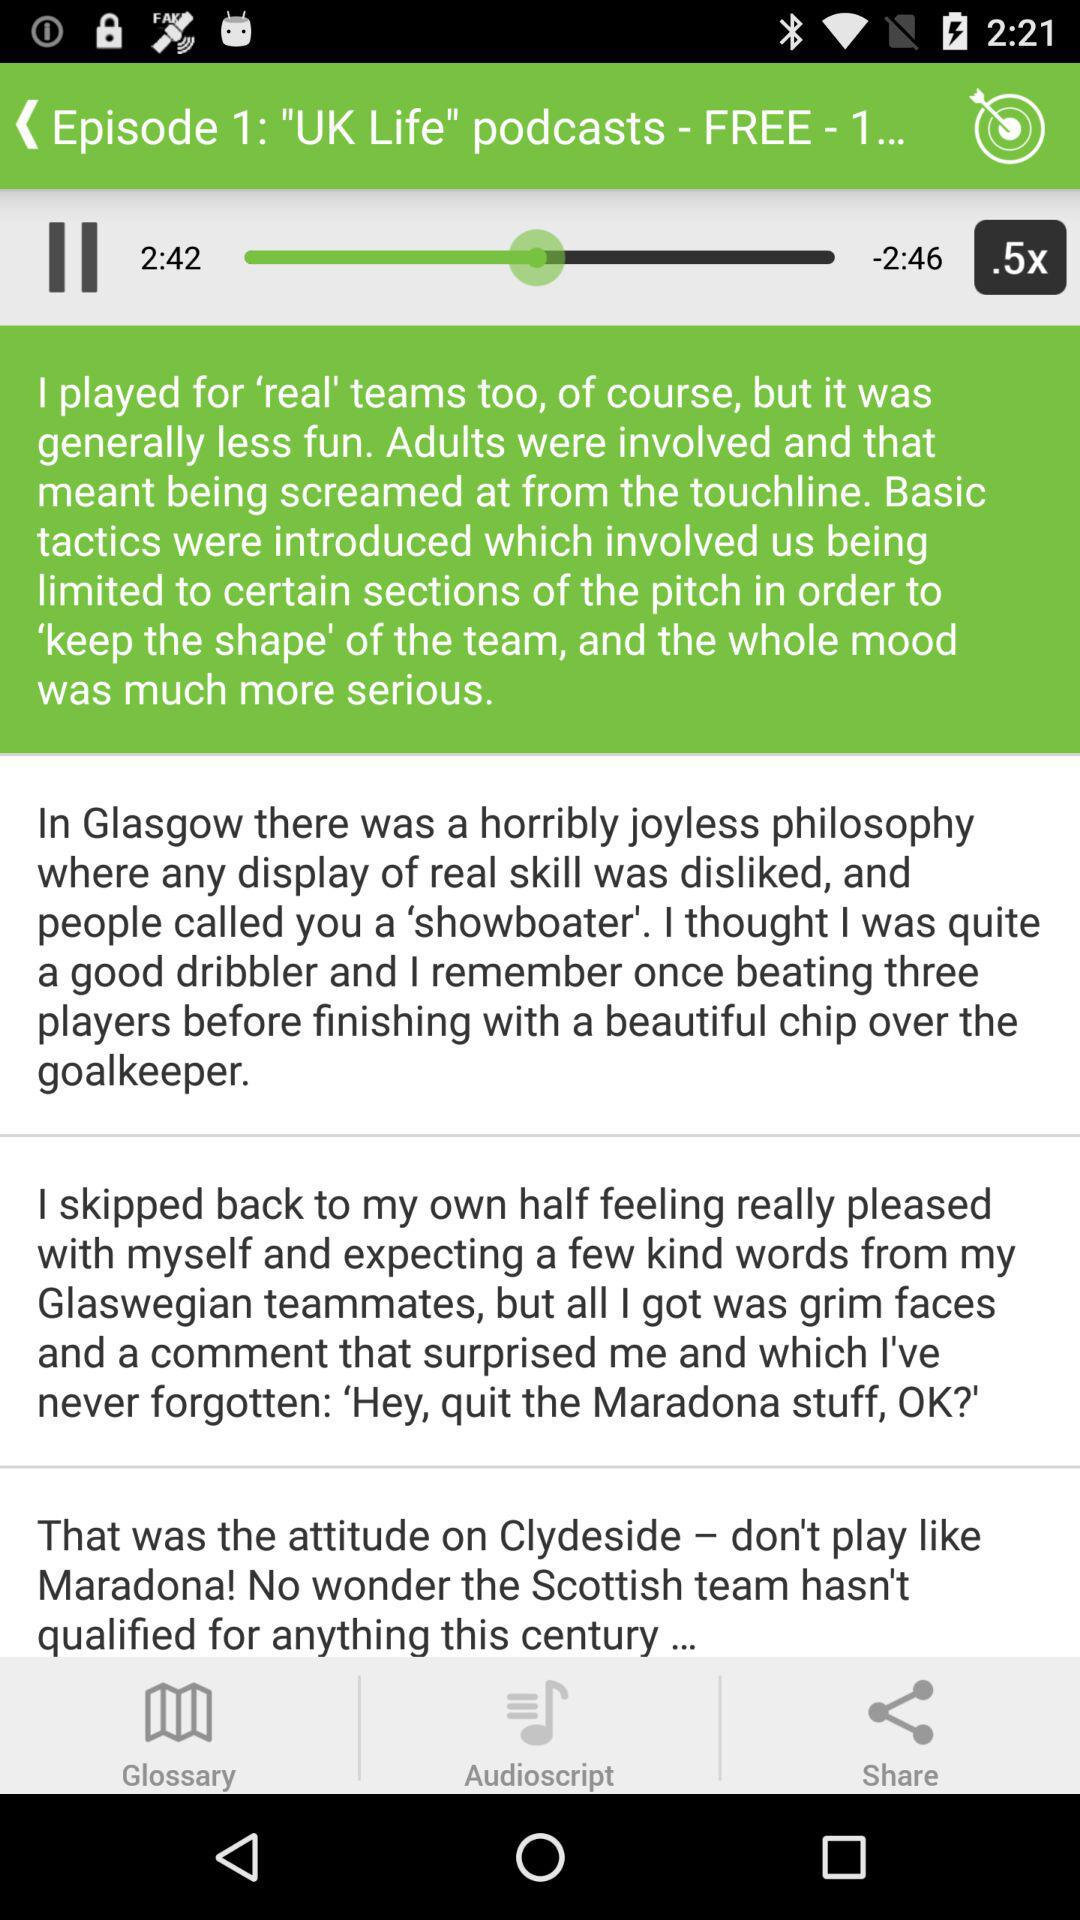How many episodes are there in this podcast?
Answer the question using a single word or phrase. 1 